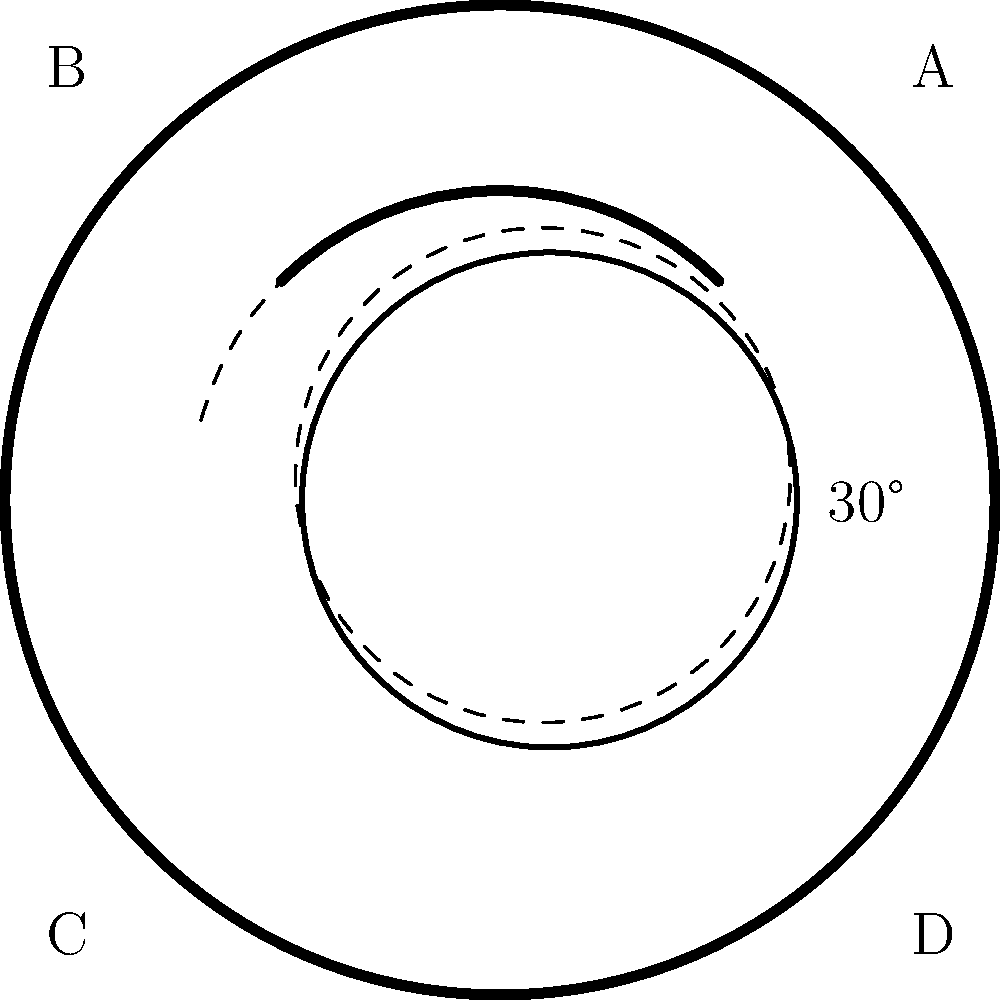A baseball glove is shown in its initial position with points A, B, C, and D marked. If the glove is rotated 30° counterclockwise around its center, what will be the new position of point A? To solve this problem, we need to understand the concept of rotation in a 2D plane. Here's a step-by-step explanation:

1. Identify the initial position of point A: (0.7, 0.7)

2. Recall the rotation formula for a point (x, y) rotated by an angle θ counterclockwise:
   x' = x * cos(θ) - y * sin(θ)
   y' = x * sin(θ) + y * cos(θ)

3. In this case, θ = 30° = π/6 radians

4. Calculate cos(30°) and sin(30°):
   cos(30°) = $\frac{\sqrt{3}}{2}$ ≈ 0.866
   sin(30°) = $\frac{1}{2}$ = 0.5

5. Apply the rotation formula:
   x' = 0.7 * cos(30°) - 0.7 * sin(30°)
      = 0.7 * 0.866 - 0.7 * 0.5
      ≈ 0.606 - 0.35
      ≈ 0.256

   y' = 0.7 * sin(30°) + 0.7 * cos(30°)
      = 0.7 * 0.5 + 0.7 * 0.866
      = 0.35 + 0.606
      ≈ 0.956

6. The new position of point A after rotation is approximately (0.256, 0.956)
Answer: (0.256, 0.956) 